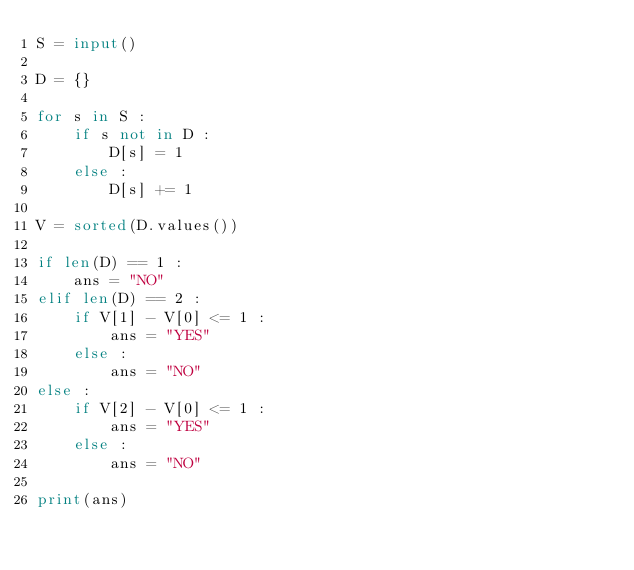<code> <loc_0><loc_0><loc_500><loc_500><_Python_>S = input()

D = {}

for s in S :
    if s not in D :
        D[s] = 1
    else :
        D[s] += 1

V = sorted(D.values())

if len(D) == 1 :
    ans = "NO"
elif len(D) == 2 :
    if V[1] - V[0] <= 1 :
        ans = "YES"
    else :
        ans = "NO"
else :
    if V[2] - V[0] <= 1 :
        ans = "YES"
    else :
        ans = "NO"

print(ans)</code> 